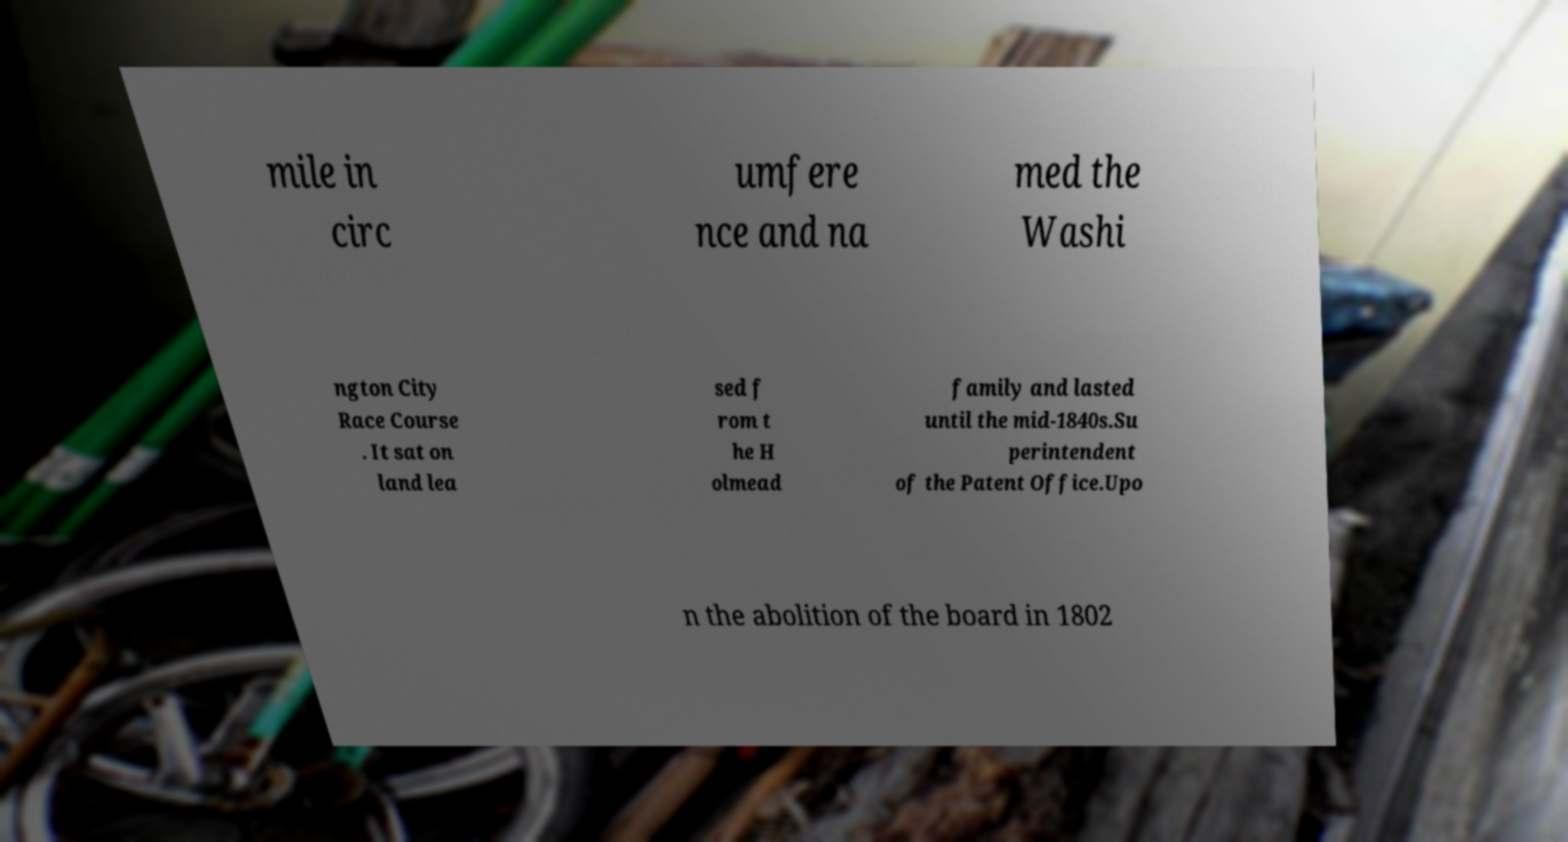Could you assist in decoding the text presented in this image and type it out clearly? mile in circ umfere nce and na med the Washi ngton City Race Course . It sat on land lea sed f rom t he H olmead family and lasted until the mid-1840s.Su perintendent of the Patent Office.Upo n the abolition of the board in 1802 